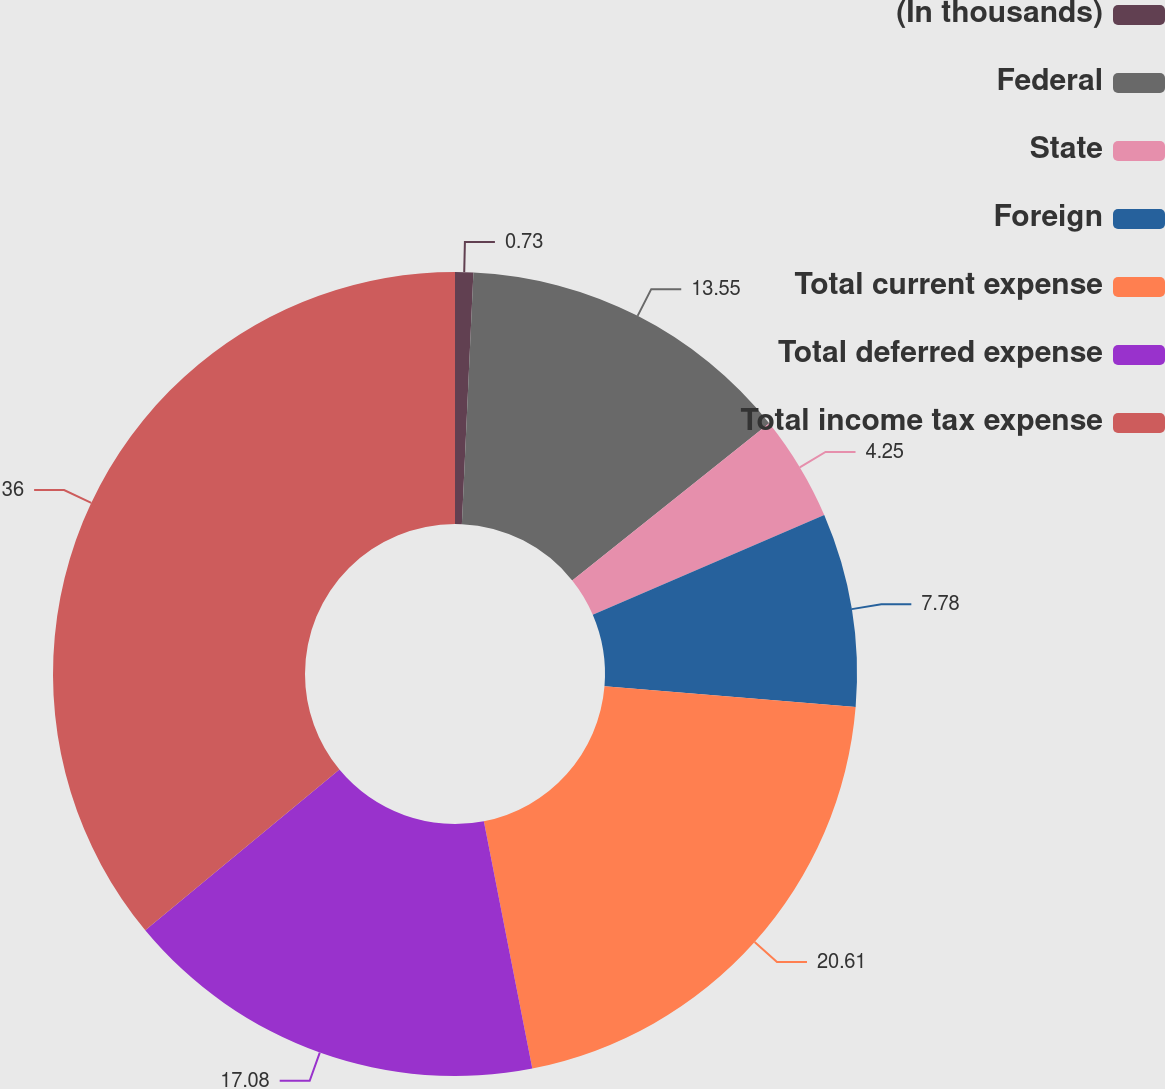<chart> <loc_0><loc_0><loc_500><loc_500><pie_chart><fcel>(In thousands)<fcel>Federal<fcel>State<fcel>Foreign<fcel>Total current expense<fcel>Total deferred expense<fcel>Total income tax expense<nl><fcel>0.73%<fcel>13.55%<fcel>4.25%<fcel>7.78%<fcel>20.61%<fcel>17.08%<fcel>36.0%<nl></chart> 